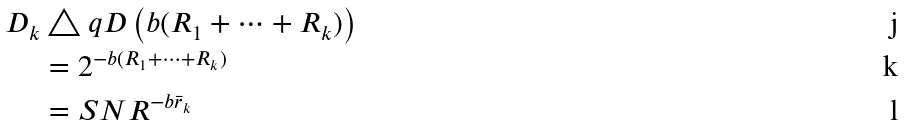<formula> <loc_0><loc_0><loc_500><loc_500>D _ { k } & \triangle q D \left ( b ( R _ { 1 } + \cdots + R _ { k } ) \right ) \\ & = 2 ^ { - b ( R _ { 1 } + \cdots + R _ { k } ) } \\ & = S N R ^ { - b \bar { r } _ { k } }</formula> 